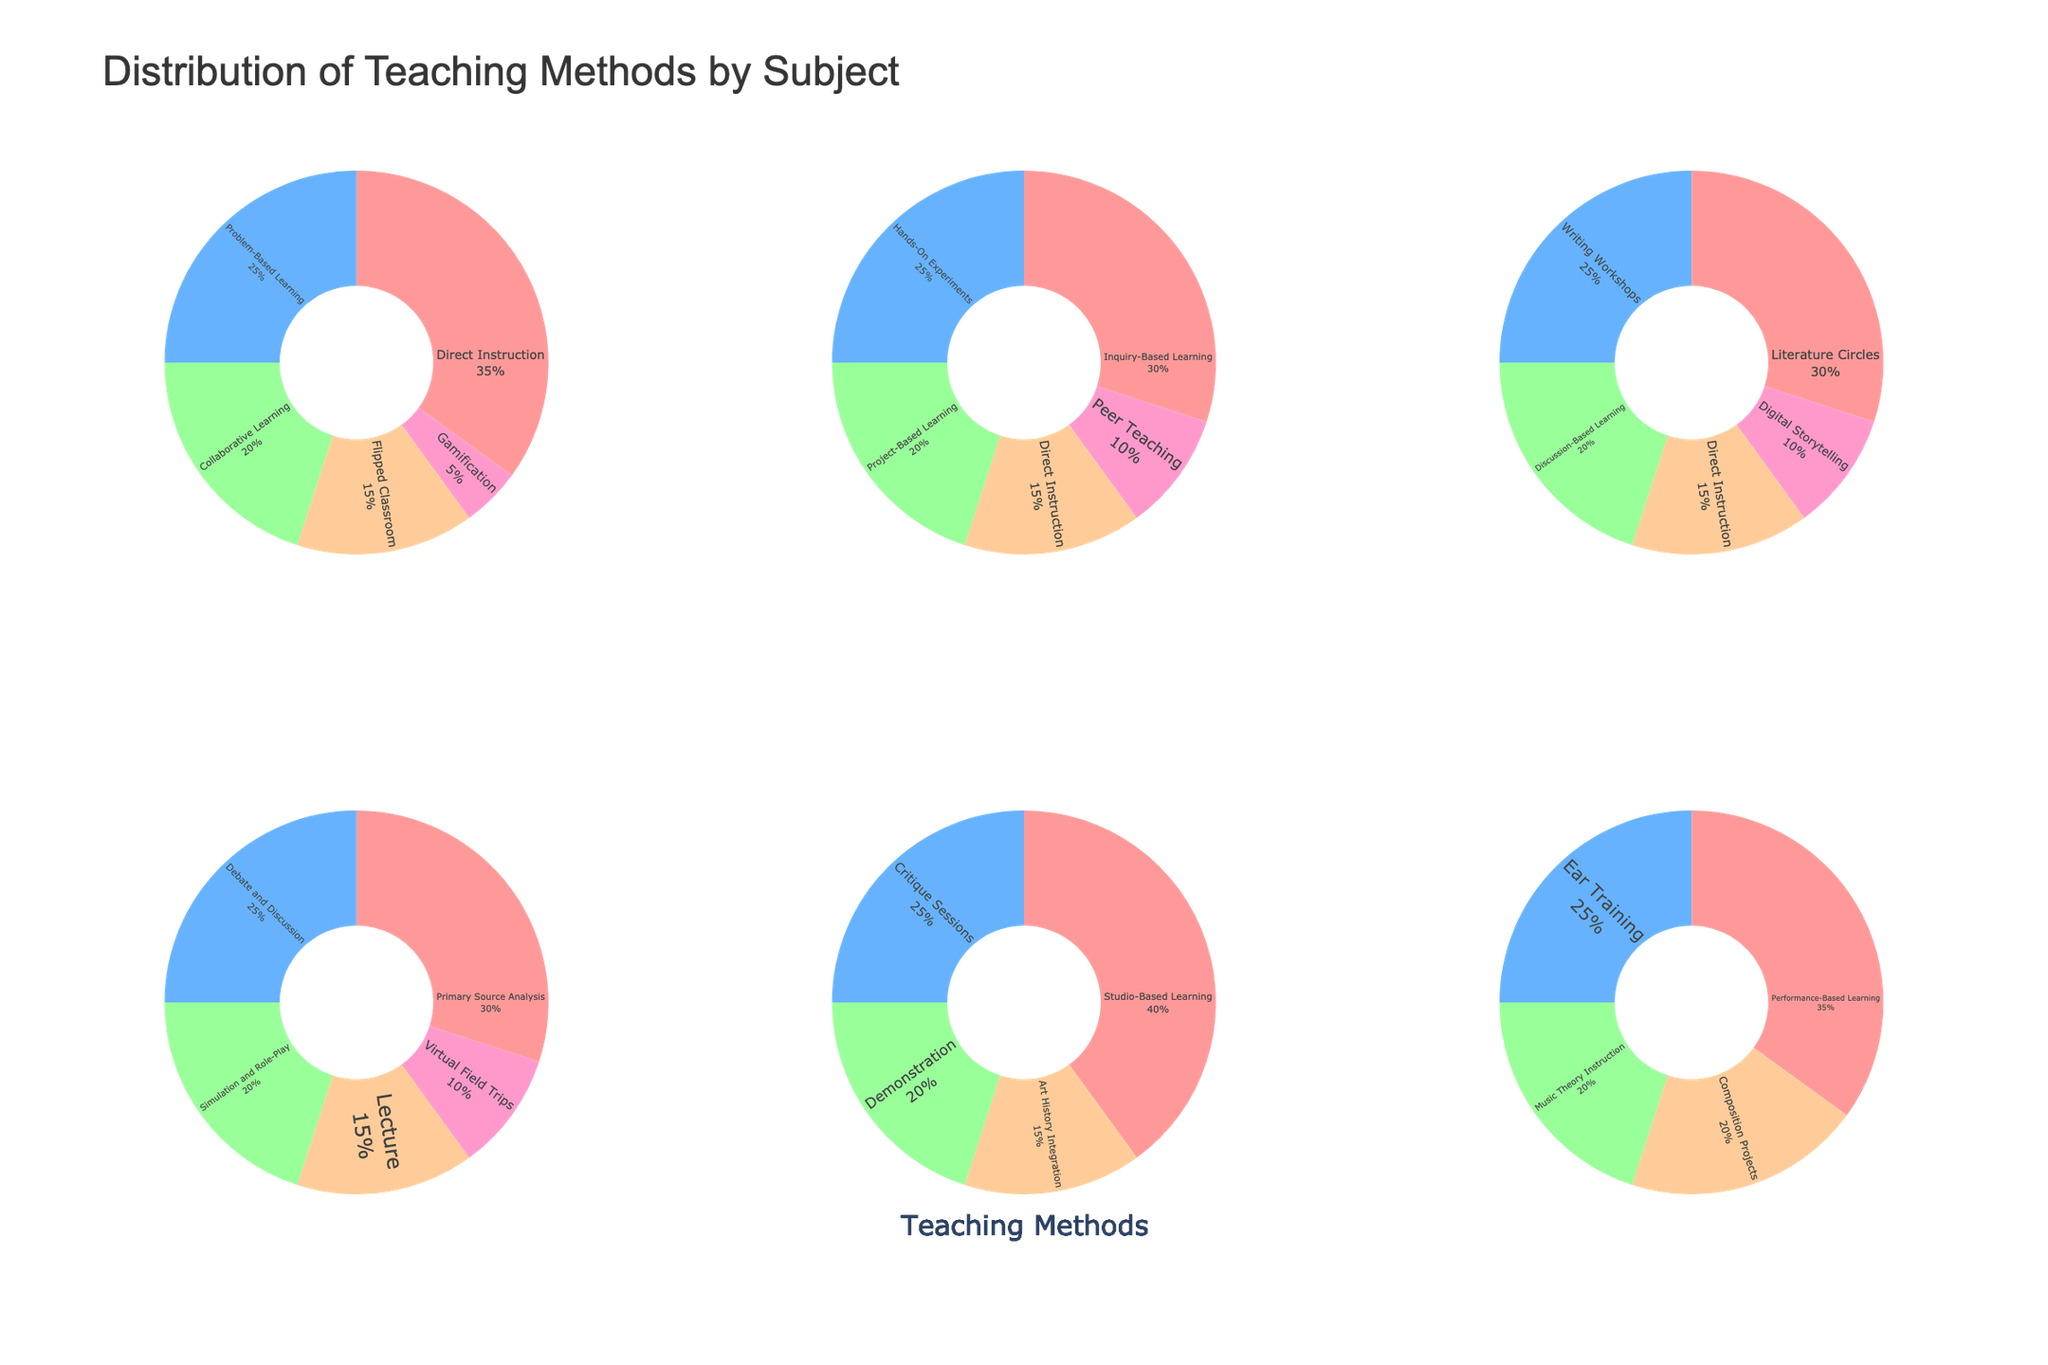what are the urgency categories in the figure? The urgency categories are the three subplots, each representing a different urgency level. They are labeled as titles above each subplot. The categories are Low, Medium, and High
Answer: Low, Medium, High Which issue type has the highest frequency in the High urgency category? In the High urgency subplot, the size of the bubbles is proportional to the frequency of maintenance requests. The largest bubble belongs to the Plumbing issue type, indicating it has the highest frequency.
Answer: Plumbing How does the average cost for Trash Removal compare to Electrical issues? Trash Removal is in the Medium urgency subplot, and Electrical is in the High urgency subplot. By comparing the y-positions (Average Cost) of the Trash Removal and Electrical bubbles, Trash Removal has a lower average cost as it is placed lower on the y-axis.
Answer: Trash Removal has a lower average cost Which issue type has the lowest average cost in the Medium urgency category? In the Medium urgency subplot, the bubble at the lowest y-position represents the issue type with the lowest average cost, which is Trash Removal.
Answer: Trash Removal What is the range of frequencies for issue types in the Low urgency category? The frequencies for Low urgency issues are represented by the size of the bubbles in the Low urgency subplot. Roofing has a frequency of 10, Structural has a frequency of 5, Paint/Drywall has a frequency of 12, Garage Door has a frequency of 8, and Gutter Cleaning has a frequency of 14, giving a range from 5 to 14.
Answer: 5 to 14 If we combine the total frequencies of Medium urgency issue types, what would be the sum? Adding up the frequencies of all issue types in the Medium urgency subplot: HVAC (25), Pest Control (20), Flooring (18), Window/Door (28), and Trash Removal (40), we get 25 + 20 + 18 + 28 + 40 = 131.
Answer: 131 Among High urgency issues, which has the higher average cost: Appliance Repair or Plumbing? In the High urgency subplot, compare the y-positions of Appliance Repair and Plumbing bubbles. Plumbing is placed higher on the y-axis, indicating a higher average cost.
Answer: Plumbing What is the average cost for all Low urgency issues? Average cost is calculated by summing the average costs and dividing by the number of issues: (500 + 1000 + 125 + 275 + 150) / 5 = 2050 / 5 = 410.
Answer: 410 Which High urgency issue type has the lowest frequency? In the High urgency subplot, the smallest bubble represents the issue type with the lowest frequency, which is Security Systems with a frequency of 22.
Answer: Security Systems What is the most significant visual difference between the Low and High urgency subplots? The most noticeable visual difference is the size and color intensity of the bubbles. The Low urgency subplot has smaller bubbles with a cooler color, whereas the High urgency subplot has larger bubbles with a more intense color, indicating higher frequencies and a higher urgency level.
Answer: Size and color intensity of bubbles 